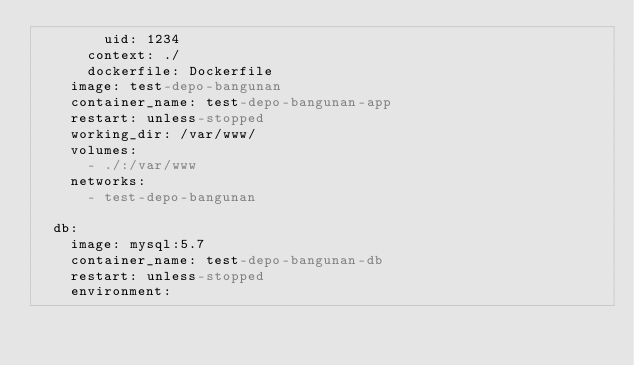Convert code to text. <code><loc_0><loc_0><loc_500><loc_500><_YAML_>        uid: 1234
      context: ./
      dockerfile: Dockerfile
    image: test-depo-bangunan
    container_name: test-depo-bangunan-app
    restart: unless-stopped
    working_dir: /var/www/
    volumes:
      - ./:/var/www
    networks:
      - test-depo-bangunan

  db:
    image: mysql:5.7
    container_name: test-depo-bangunan-db
    restart: unless-stopped
    environment:</code> 